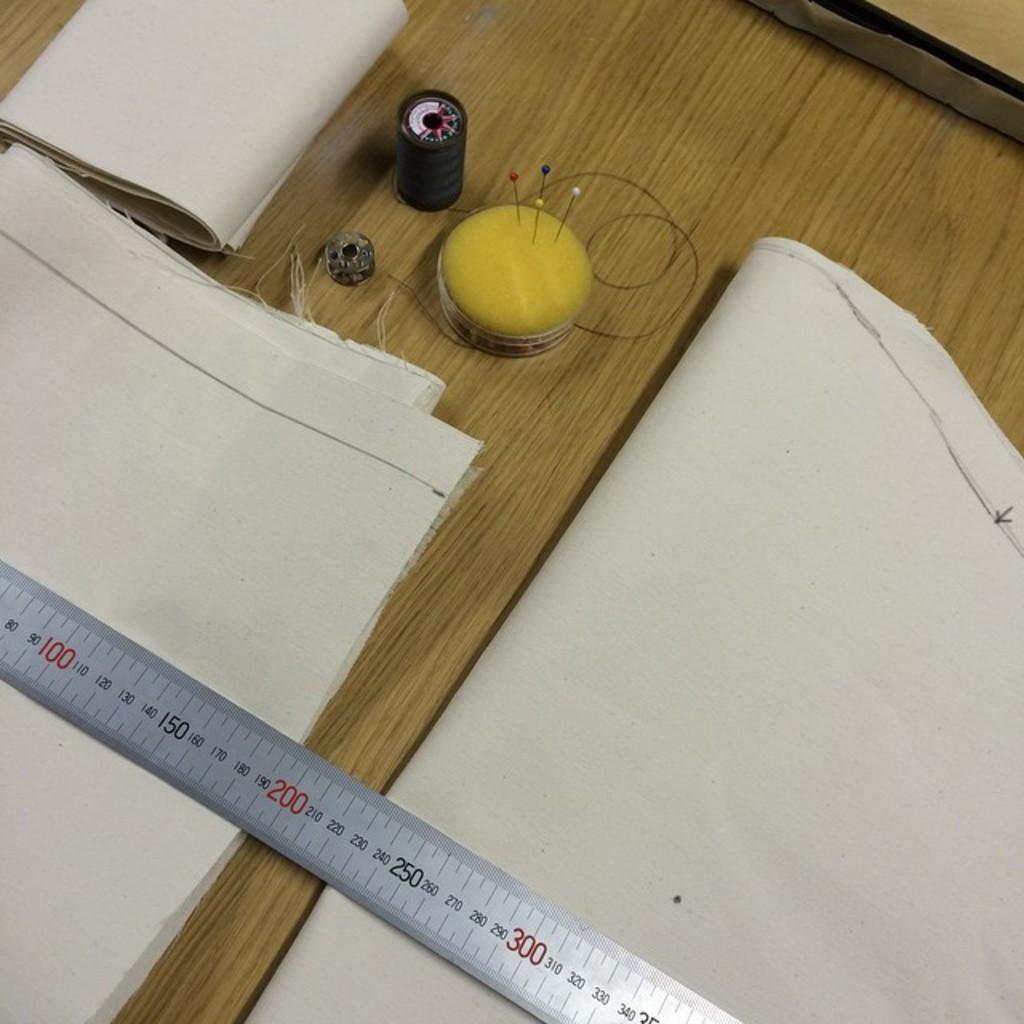<image>
Provide a brief description of the given image. A sewing kit and a silver ruler starting at 80 up to 340. 